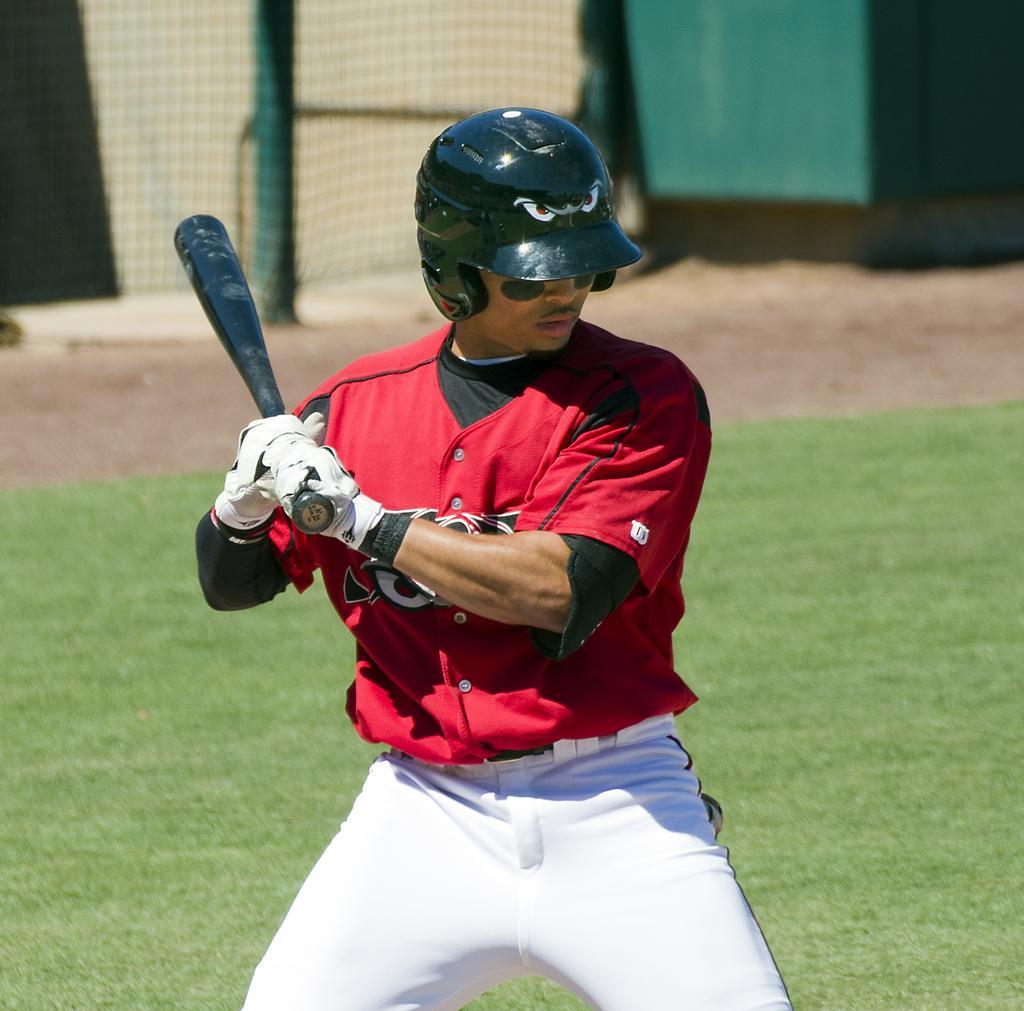Please provide a concise description of this image. This image is taken outdoors. At the bottom of the image there is a ground with grass on it. In the middle of the image a man is playing baseball with a baseball bat. In the background there is a net. 